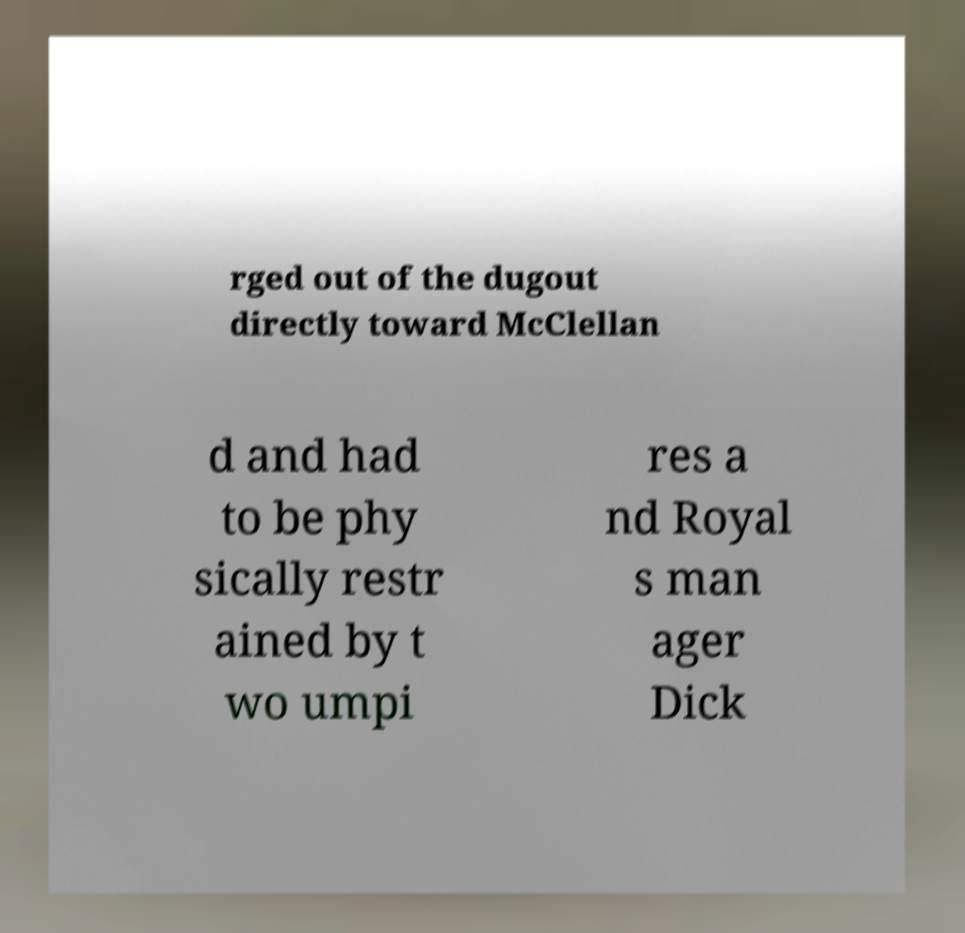For documentation purposes, I need the text within this image transcribed. Could you provide that? rged out of the dugout directly toward McClellan d and had to be phy sically restr ained by t wo umpi res a nd Royal s man ager Dick 